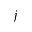<formula> <loc_0><loc_0><loc_500><loc_500>j</formula> 